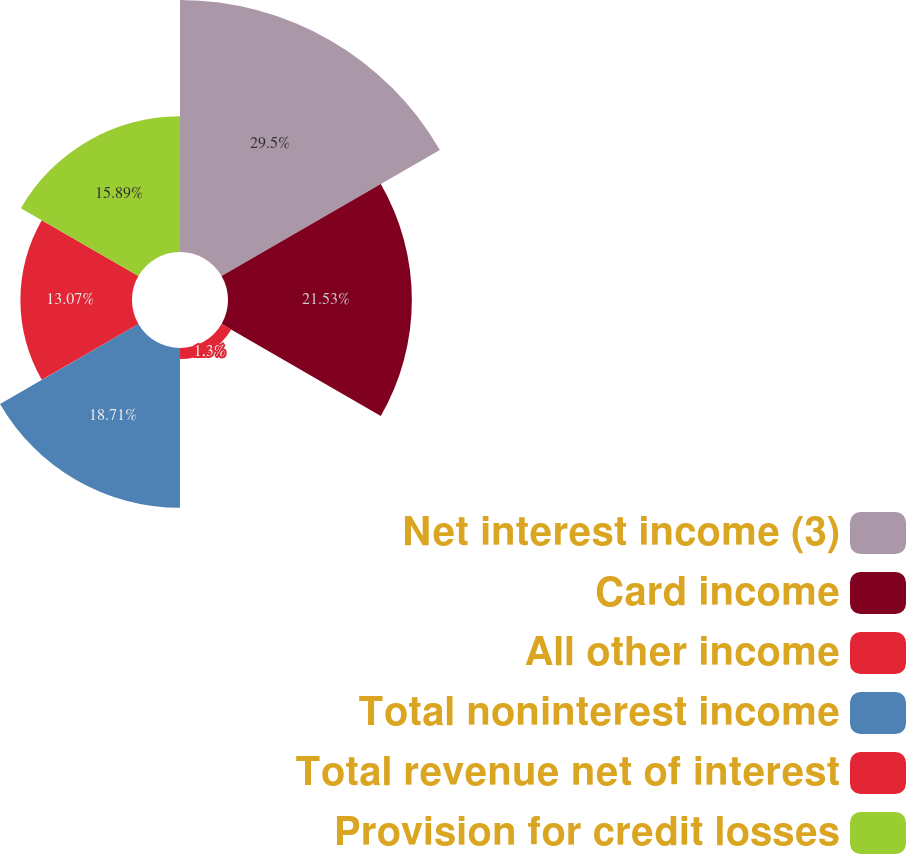Convert chart. <chart><loc_0><loc_0><loc_500><loc_500><pie_chart><fcel>Net interest income (3)<fcel>Card income<fcel>All other income<fcel>Total noninterest income<fcel>Total revenue net of interest<fcel>Provision for credit losses<nl><fcel>29.51%<fcel>21.53%<fcel>1.3%<fcel>18.71%<fcel>13.07%<fcel>15.89%<nl></chart> 